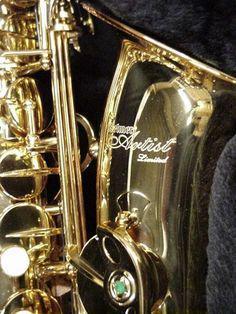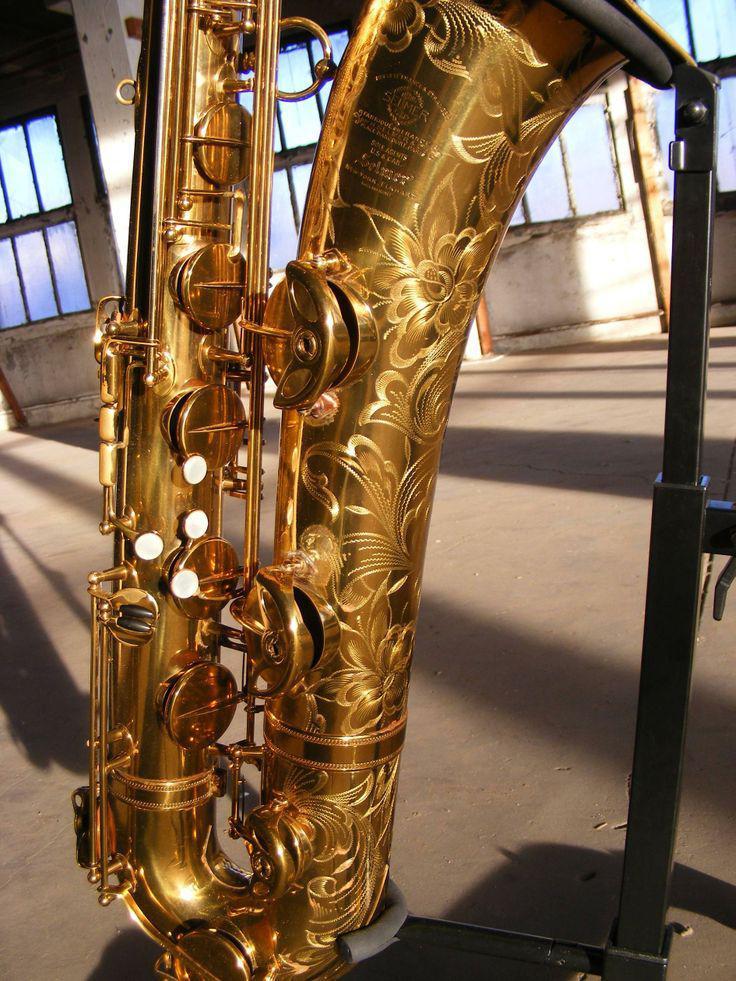The first image is the image on the left, the second image is the image on the right. For the images shown, is this caption "At least four musicians hold saxophones in one image." true? Answer yes or no. No. The first image is the image on the left, the second image is the image on the right. Considering the images on both sides, is "A saxophone is sitting on a black stand in the image on the right." valid? Answer yes or no. Yes. 